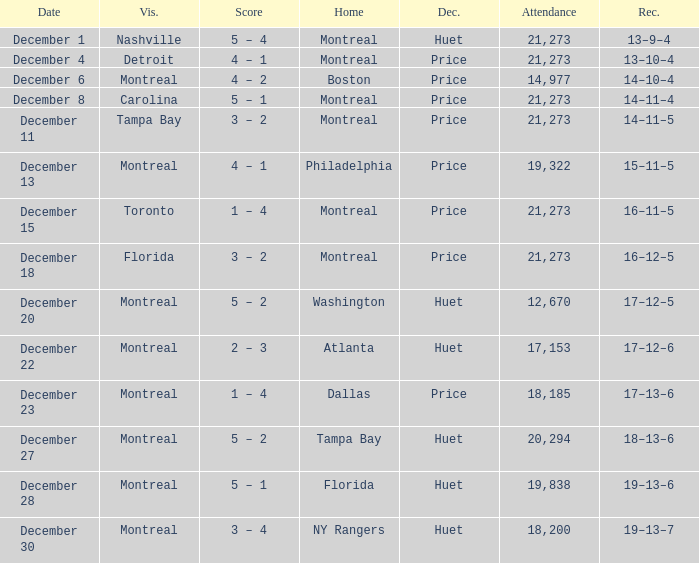What is the decision when the record is 13–10–4? Price. 